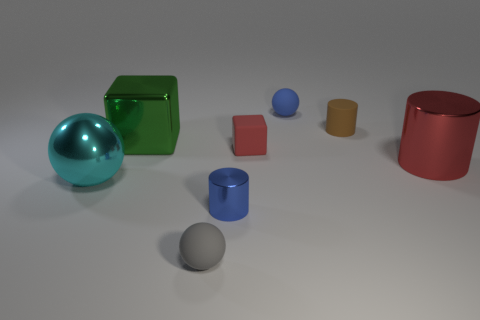How many things are small blue rubber spheres or blue things?
Offer a terse response. 2. How many other things are there of the same color as the big cylinder?
Give a very brief answer. 1. The brown thing that is the same size as the blue shiny object is what shape?
Provide a succinct answer. Cylinder. There is a tiny sphere that is in front of the large red shiny cylinder; what color is it?
Keep it short and to the point. Gray. What number of objects are either tiny spheres that are to the left of the blue metal cylinder or rubber things behind the small gray object?
Make the answer very short. 4. Do the blue shiny object and the brown rubber cylinder have the same size?
Keep it short and to the point. Yes. How many cylinders are either small blue rubber objects or red metal things?
Provide a succinct answer. 1. How many things are right of the large green thing and behind the red rubber cube?
Offer a terse response. 2. There is a red rubber cube; is it the same size as the metal cylinder on the left side of the large red shiny cylinder?
Give a very brief answer. Yes. There is a ball that is right of the cylinder on the left side of the blue ball; are there any small brown rubber cylinders that are on the left side of it?
Offer a very short reply. No. 